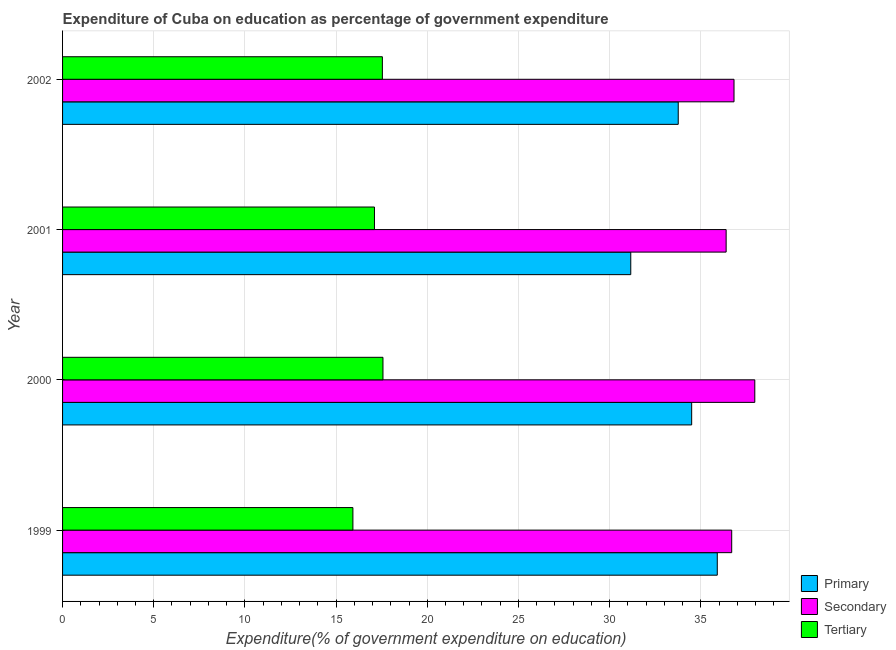How many different coloured bars are there?
Your answer should be very brief. 3. Are the number of bars per tick equal to the number of legend labels?
Offer a very short reply. Yes. How many bars are there on the 4th tick from the top?
Provide a short and direct response. 3. What is the label of the 1st group of bars from the top?
Offer a terse response. 2002. What is the expenditure on tertiary education in 2001?
Give a very brief answer. 17.1. Across all years, what is the maximum expenditure on secondary education?
Your response must be concise. 37.96. Across all years, what is the minimum expenditure on tertiary education?
Make the answer very short. 15.92. In which year was the expenditure on secondary education minimum?
Offer a very short reply. 2001. What is the total expenditure on primary education in the graph?
Make the answer very short. 135.33. What is the difference between the expenditure on primary education in 2000 and that in 2002?
Offer a very short reply. 0.74. What is the difference between the expenditure on primary education in 2000 and the expenditure on secondary education in 2002?
Offer a terse response. -2.32. What is the average expenditure on tertiary education per year?
Offer a terse response. 17.03. In the year 2002, what is the difference between the expenditure on tertiary education and expenditure on primary education?
Provide a succinct answer. -16.23. Is the expenditure on primary education in 1999 less than that in 2000?
Offer a terse response. No. Is the difference between the expenditure on primary education in 1999 and 2000 greater than the difference between the expenditure on tertiary education in 1999 and 2000?
Your answer should be compact. Yes. What is the difference between the highest and the second highest expenditure on tertiary education?
Your answer should be very brief. 0.03. What is the difference between the highest and the lowest expenditure on primary education?
Give a very brief answer. 4.75. Is the sum of the expenditure on tertiary education in 2000 and 2002 greater than the maximum expenditure on primary education across all years?
Your answer should be very brief. No. What does the 1st bar from the top in 1999 represents?
Provide a short and direct response. Tertiary. What does the 1st bar from the bottom in 2002 represents?
Ensure brevity in your answer.  Primary. Are the values on the major ticks of X-axis written in scientific E-notation?
Your response must be concise. No. Does the graph contain any zero values?
Your answer should be compact. No. What is the title of the graph?
Provide a short and direct response. Expenditure of Cuba on education as percentage of government expenditure. What is the label or title of the X-axis?
Make the answer very short. Expenditure(% of government expenditure on education). What is the label or title of the Y-axis?
Your response must be concise. Year. What is the Expenditure(% of government expenditure on education) of Primary in 1999?
Provide a short and direct response. 35.9. What is the Expenditure(% of government expenditure on education) in Secondary in 1999?
Give a very brief answer. 36.7. What is the Expenditure(% of government expenditure on education) of Tertiary in 1999?
Your response must be concise. 15.92. What is the Expenditure(% of government expenditure on education) of Primary in 2000?
Your response must be concise. 34.5. What is the Expenditure(% of government expenditure on education) of Secondary in 2000?
Your response must be concise. 37.96. What is the Expenditure(% of government expenditure on education) of Tertiary in 2000?
Keep it short and to the point. 17.57. What is the Expenditure(% of government expenditure on education) of Primary in 2001?
Offer a terse response. 31.16. What is the Expenditure(% of government expenditure on education) in Secondary in 2001?
Ensure brevity in your answer.  36.39. What is the Expenditure(% of government expenditure on education) of Tertiary in 2001?
Give a very brief answer. 17.1. What is the Expenditure(% of government expenditure on education) of Primary in 2002?
Give a very brief answer. 33.76. What is the Expenditure(% of government expenditure on education) in Secondary in 2002?
Your answer should be very brief. 36.82. What is the Expenditure(% of government expenditure on education) in Tertiary in 2002?
Offer a terse response. 17.54. Across all years, what is the maximum Expenditure(% of government expenditure on education) in Primary?
Provide a short and direct response. 35.9. Across all years, what is the maximum Expenditure(% of government expenditure on education) in Secondary?
Offer a terse response. 37.96. Across all years, what is the maximum Expenditure(% of government expenditure on education) of Tertiary?
Provide a succinct answer. 17.57. Across all years, what is the minimum Expenditure(% of government expenditure on education) of Primary?
Ensure brevity in your answer.  31.16. Across all years, what is the minimum Expenditure(% of government expenditure on education) in Secondary?
Offer a terse response. 36.39. Across all years, what is the minimum Expenditure(% of government expenditure on education) in Tertiary?
Give a very brief answer. 15.92. What is the total Expenditure(% of government expenditure on education) of Primary in the graph?
Offer a very short reply. 135.33. What is the total Expenditure(% of government expenditure on education) of Secondary in the graph?
Keep it short and to the point. 147.87. What is the total Expenditure(% of government expenditure on education) in Tertiary in the graph?
Your response must be concise. 68.14. What is the difference between the Expenditure(% of government expenditure on education) of Primary in 1999 and that in 2000?
Provide a succinct answer. 1.4. What is the difference between the Expenditure(% of government expenditure on education) of Secondary in 1999 and that in 2000?
Provide a succinct answer. -1.27. What is the difference between the Expenditure(% of government expenditure on education) in Tertiary in 1999 and that in 2000?
Provide a succinct answer. -1.65. What is the difference between the Expenditure(% of government expenditure on education) of Primary in 1999 and that in 2001?
Keep it short and to the point. 4.75. What is the difference between the Expenditure(% of government expenditure on education) in Secondary in 1999 and that in 2001?
Keep it short and to the point. 0.31. What is the difference between the Expenditure(% of government expenditure on education) of Tertiary in 1999 and that in 2001?
Offer a very short reply. -1.18. What is the difference between the Expenditure(% of government expenditure on education) of Primary in 1999 and that in 2002?
Make the answer very short. 2.14. What is the difference between the Expenditure(% of government expenditure on education) of Secondary in 1999 and that in 2002?
Ensure brevity in your answer.  -0.13. What is the difference between the Expenditure(% of government expenditure on education) in Tertiary in 1999 and that in 2002?
Ensure brevity in your answer.  -1.62. What is the difference between the Expenditure(% of government expenditure on education) in Primary in 2000 and that in 2001?
Keep it short and to the point. 3.34. What is the difference between the Expenditure(% of government expenditure on education) of Secondary in 2000 and that in 2001?
Ensure brevity in your answer.  1.57. What is the difference between the Expenditure(% of government expenditure on education) in Tertiary in 2000 and that in 2001?
Your response must be concise. 0.47. What is the difference between the Expenditure(% of government expenditure on education) of Primary in 2000 and that in 2002?
Your response must be concise. 0.74. What is the difference between the Expenditure(% of government expenditure on education) in Secondary in 2000 and that in 2002?
Provide a succinct answer. 1.14. What is the difference between the Expenditure(% of government expenditure on education) of Tertiary in 2000 and that in 2002?
Provide a succinct answer. 0.03. What is the difference between the Expenditure(% of government expenditure on education) in Primary in 2001 and that in 2002?
Your answer should be compact. -2.6. What is the difference between the Expenditure(% of government expenditure on education) of Secondary in 2001 and that in 2002?
Ensure brevity in your answer.  -0.43. What is the difference between the Expenditure(% of government expenditure on education) of Tertiary in 2001 and that in 2002?
Ensure brevity in your answer.  -0.43. What is the difference between the Expenditure(% of government expenditure on education) in Primary in 1999 and the Expenditure(% of government expenditure on education) in Secondary in 2000?
Your response must be concise. -2.06. What is the difference between the Expenditure(% of government expenditure on education) of Primary in 1999 and the Expenditure(% of government expenditure on education) of Tertiary in 2000?
Give a very brief answer. 18.33. What is the difference between the Expenditure(% of government expenditure on education) of Secondary in 1999 and the Expenditure(% of government expenditure on education) of Tertiary in 2000?
Ensure brevity in your answer.  19.12. What is the difference between the Expenditure(% of government expenditure on education) in Primary in 1999 and the Expenditure(% of government expenditure on education) in Secondary in 2001?
Ensure brevity in your answer.  -0.49. What is the difference between the Expenditure(% of government expenditure on education) of Primary in 1999 and the Expenditure(% of government expenditure on education) of Tertiary in 2001?
Your answer should be very brief. 18.8. What is the difference between the Expenditure(% of government expenditure on education) in Secondary in 1999 and the Expenditure(% of government expenditure on education) in Tertiary in 2001?
Provide a succinct answer. 19.59. What is the difference between the Expenditure(% of government expenditure on education) in Primary in 1999 and the Expenditure(% of government expenditure on education) in Secondary in 2002?
Offer a very short reply. -0.92. What is the difference between the Expenditure(% of government expenditure on education) in Primary in 1999 and the Expenditure(% of government expenditure on education) in Tertiary in 2002?
Your response must be concise. 18.37. What is the difference between the Expenditure(% of government expenditure on education) in Secondary in 1999 and the Expenditure(% of government expenditure on education) in Tertiary in 2002?
Offer a terse response. 19.16. What is the difference between the Expenditure(% of government expenditure on education) in Primary in 2000 and the Expenditure(% of government expenditure on education) in Secondary in 2001?
Give a very brief answer. -1.89. What is the difference between the Expenditure(% of government expenditure on education) of Primary in 2000 and the Expenditure(% of government expenditure on education) of Tertiary in 2001?
Ensure brevity in your answer.  17.4. What is the difference between the Expenditure(% of government expenditure on education) in Secondary in 2000 and the Expenditure(% of government expenditure on education) in Tertiary in 2001?
Ensure brevity in your answer.  20.86. What is the difference between the Expenditure(% of government expenditure on education) of Primary in 2000 and the Expenditure(% of government expenditure on education) of Secondary in 2002?
Offer a terse response. -2.32. What is the difference between the Expenditure(% of government expenditure on education) in Primary in 2000 and the Expenditure(% of government expenditure on education) in Tertiary in 2002?
Provide a short and direct response. 16.96. What is the difference between the Expenditure(% of government expenditure on education) of Secondary in 2000 and the Expenditure(% of government expenditure on education) of Tertiary in 2002?
Offer a very short reply. 20.42. What is the difference between the Expenditure(% of government expenditure on education) of Primary in 2001 and the Expenditure(% of government expenditure on education) of Secondary in 2002?
Offer a terse response. -5.66. What is the difference between the Expenditure(% of government expenditure on education) in Primary in 2001 and the Expenditure(% of government expenditure on education) in Tertiary in 2002?
Offer a very short reply. 13.62. What is the difference between the Expenditure(% of government expenditure on education) in Secondary in 2001 and the Expenditure(% of government expenditure on education) in Tertiary in 2002?
Provide a succinct answer. 18.85. What is the average Expenditure(% of government expenditure on education) of Primary per year?
Offer a very short reply. 33.83. What is the average Expenditure(% of government expenditure on education) of Secondary per year?
Your answer should be compact. 36.97. What is the average Expenditure(% of government expenditure on education) in Tertiary per year?
Ensure brevity in your answer.  17.03. In the year 1999, what is the difference between the Expenditure(% of government expenditure on education) of Primary and Expenditure(% of government expenditure on education) of Secondary?
Provide a succinct answer. -0.79. In the year 1999, what is the difference between the Expenditure(% of government expenditure on education) of Primary and Expenditure(% of government expenditure on education) of Tertiary?
Your answer should be compact. 19.98. In the year 1999, what is the difference between the Expenditure(% of government expenditure on education) in Secondary and Expenditure(% of government expenditure on education) in Tertiary?
Your response must be concise. 20.77. In the year 2000, what is the difference between the Expenditure(% of government expenditure on education) of Primary and Expenditure(% of government expenditure on education) of Secondary?
Give a very brief answer. -3.46. In the year 2000, what is the difference between the Expenditure(% of government expenditure on education) of Primary and Expenditure(% of government expenditure on education) of Tertiary?
Ensure brevity in your answer.  16.93. In the year 2000, what is the difference between the Expenditure(% of government expenditure on education) in Secondary and Expenditure(% of government expenditure on education) in Tertiary?
Offer a terse response. 20.39. In the year 2001, what is the difference between the Expenditure(% of government expenditure on education) of Primary and Expenditure(% of government expenditure on education) of Secondary?
Provide a succinct answer. -5.23. In the year 2001, what is the difference between the Expenditure(% of government expenditure on education) in Primary and Expenditure(% of government expenditure on education) in Tertiary?
Provide a short and direct response. 14.05. In the year 2001, what is the difference between the Expenditure(% of government expenditure on education) in Secondary and Expenditure(% of government expenditure on education) in Tertiary?
Your response must be concise. 19.29. In the year 2002, what is the difference between the Expenditure(% of government expenditure on education) in Primary and Expenditure(% of government expenditure on education) in Secondary?
Your answer should be very brief. -3.06. In the year 2002, what is the difference between the Expenditure(% of government expenditure on education) in Primary and Expenditure(% of government expenditure on education) in Tertiary?
Give a very brief answer. 16.23. In the year 2002, what is the difference between the Expenditure(% of government expenditure on education) in Secondary and Expenditure(% of government expenditure on education) in Tertiary?
Offer a very short reply. 19.28. What is the ratio of the Expenditure(% of government expenditure on education) in Primary in 1999 to that in 2000?
Offer a very short reply. 1.04. What is the ratio of the Expenditure(% of government expenditure on education) in Secondary in 1999 to that in 2000?
Ensure brevity in your answer.  0.97. What is the ratio of the Expenditure(% of government expenditure on education) of Tertiary in 1999 to that in 2000?
Give a very brief answer. 0.91. What is the ratio of the Expenditure(% of government expenditure on education) in Primary in 1999 to that in 2001?
Ensure brevity in your answer.  1.15. What is the ratio of the Expenditure(% of government expenditure on education) in Secondary in 1999 to that in 2001?
Offer a very short reply. 1.01. What is the ratio of the Expenditure(% of government expenditure on education) in Tertiary in 1999 to that in 2001?
Your answer should be very brief. 0.93. What is the ratio of the Expenditure(% of government expenditure on education) in Primary in 1999 to that in 2002?
Your answer should be very brief. 1.06. What is the ratio of the Expenditure(% of government expenditure on education) of Secondary in 1999 to that in 2002?
Your answer should be compact. 1. What is the ratio of the Expenditure(% of government expenditure on education) of Tertiary in 1999 to that in 2002?
Your answer should be compact. 0.91. What is the ratio of the Expenditure(% of government expenditure on education) of Primary in 2000 to that in 2001?
Offer a terse response. 1.11. What is the ratio of the Expenditure(% of government expenditure on education) of Secondary in 2000 to that in 2001?
Offer a very short reply. 1.04. What is the ratio of the Expenditure(% of government expenditure on education) of Tertiary in 2000 to that in 2001?
Your answer should be compact. 1.03. What is the ratio of the Expenditure(% of government expenditure on education) in Primary in 2000 to that in 2002?
Give a very brief answer. 1.02. What is the ratio of the Expenditure(% of government expenditure on education) in Secondary in 2000 to that in 2002?
Ensure brevity in your answer.  1.03. What is the ratio of the Expenditure(% of government expenditure on education) in Primary in 2001 to that in 2002?
Provide a succinct answer. 0.92. What is the ratio of the Expenditure(% of government expenditure on education) in Secondary in 2001 to that in 2002?
Ensure brevity in your answer.  0.99. What is the ratio of the Expenditure(% of government expenditure on education) in Tertiary in 2001 to that in 2002?
Your answer should be very brief. 0.98. What is the difference between the highest and the second highest Expenditure(% of government expenditure on education) of Primary?
Provide a succinct answer. 1.4. What is the difference between the highest and the second highest Expenditure(% of government expenditure on education) of Secondary?
Your answer should be very brief. 1.14. What is the difference between the highest and the second highest Expenditure(% of government expenditure on education) in Tertiary?
Keep it short and to the point. 0.03. What is the difference between the highest and the lowest Expenditure(% of government expenditure on education) of Primary?
Your answer should be compact. 4.75. What is the difference between the highest and the lowest Expenditure(% of government expenditure on education) of Secondary?
Offer a very short reply. 1.57. What is the difference between the highest and the lowest Expenditure(% of government expenditure on education) in Tertiary?
Your answer should be compact. 1.65. 